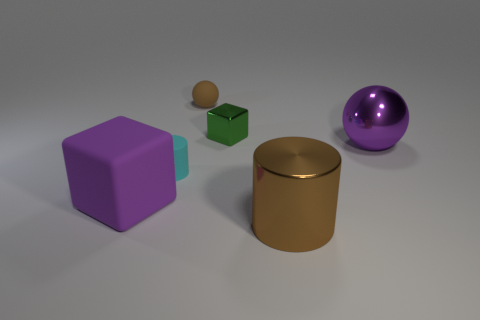Add 3 large purple matte things. How many objects exist? 9 Subtract all cubes. How many objects are left? 4 Add 3 small cyan matte cylinders. How many small cyan matte cylinders are left? 4 Add 6 large brown metallic cylinders. How many large brown metallic cylinders exist? 7 Subtract 0 yellow cubes. How many objects are left? 6 Subtract all big purple metal balls. Subtract all large purple spheres. How many objects are left? 4 